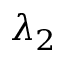<formula> <loc_0><loc_0><loc_500><loc_500>\lambda _ { 2 }</formula> 